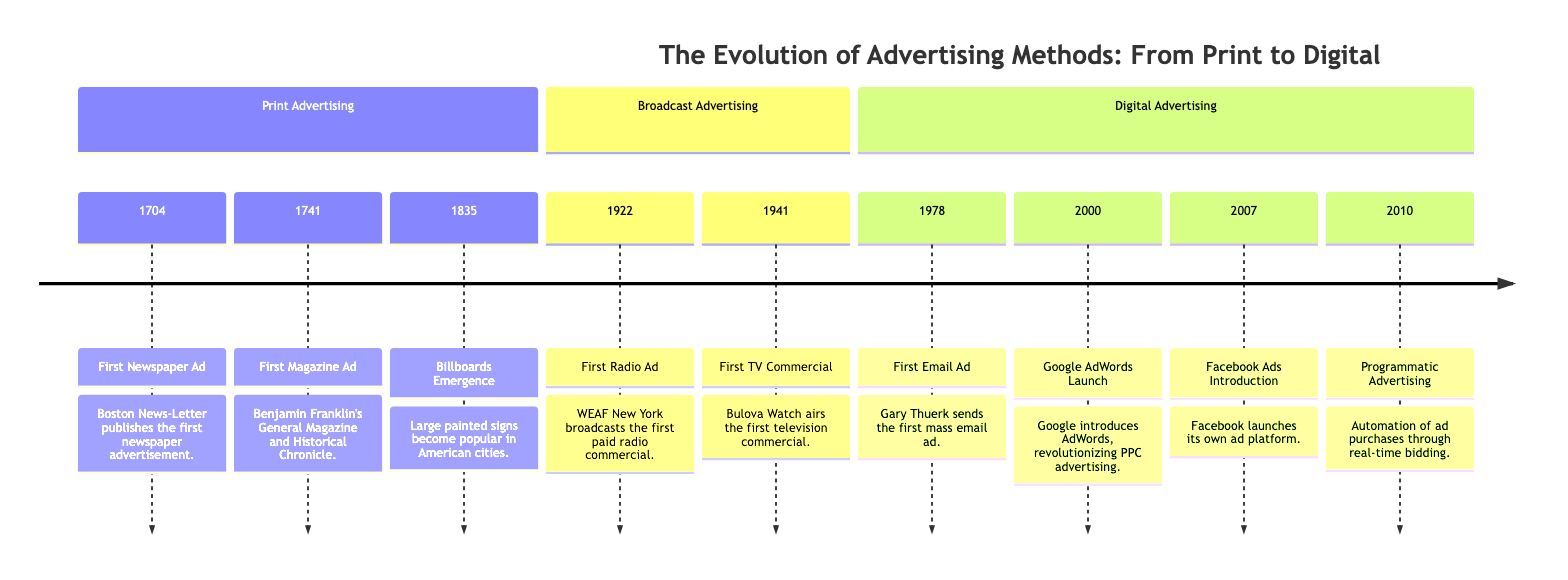What year was the first newspaper ad published? According to the timeline, the first newspaper ad was published in 1704.
Answer: 1704 What innovative form of advertising emerged in cities during the 1835? The timeline states that billboards emerged as a form of advertising in 1835.
Answer: Billboards How many key milestones are listed under digital advertising? There are four key milestones displayed in the digital advertising section of the timeline.
Answer: 4 What was the first paid radio commercial and when did it air? The first paid radio commercial was aired by WEAF New York in 1922.
Answer: WEAF New York, 1922 Which advertising method appeared first, television or radio? By comparing the earliest dates, the timeline indicates that the first radio ad in 1922 predates the first TV commercial in 1941.
Answer: Radio What significant change in advertising occurred in 2010? The timeline notes that in 2010, programmatic advertising was introduced, which refers to automation in ad purchases.
Answer: Programmatic Advertising What advertising platform did Google launch in 2000? The timeline indicates that Google introduced AdWords in 2000, which revolutionized PPC advertising.
Answer: AdWords Which innovation in advertising came after the first email ad in 1978? The timeline shows that the Google AdWords launch in 2000 occurred after the first email ad was sent in 1978.
Answer: Google AdWords What does the timeline suggest about the trend of advertising methods over time? The timeline illustrates a clear progression from print to broadcast to digital advertising methods, indicating an evolution and adaptation of advertising strategies.
Answer: Evolution and adaptation 